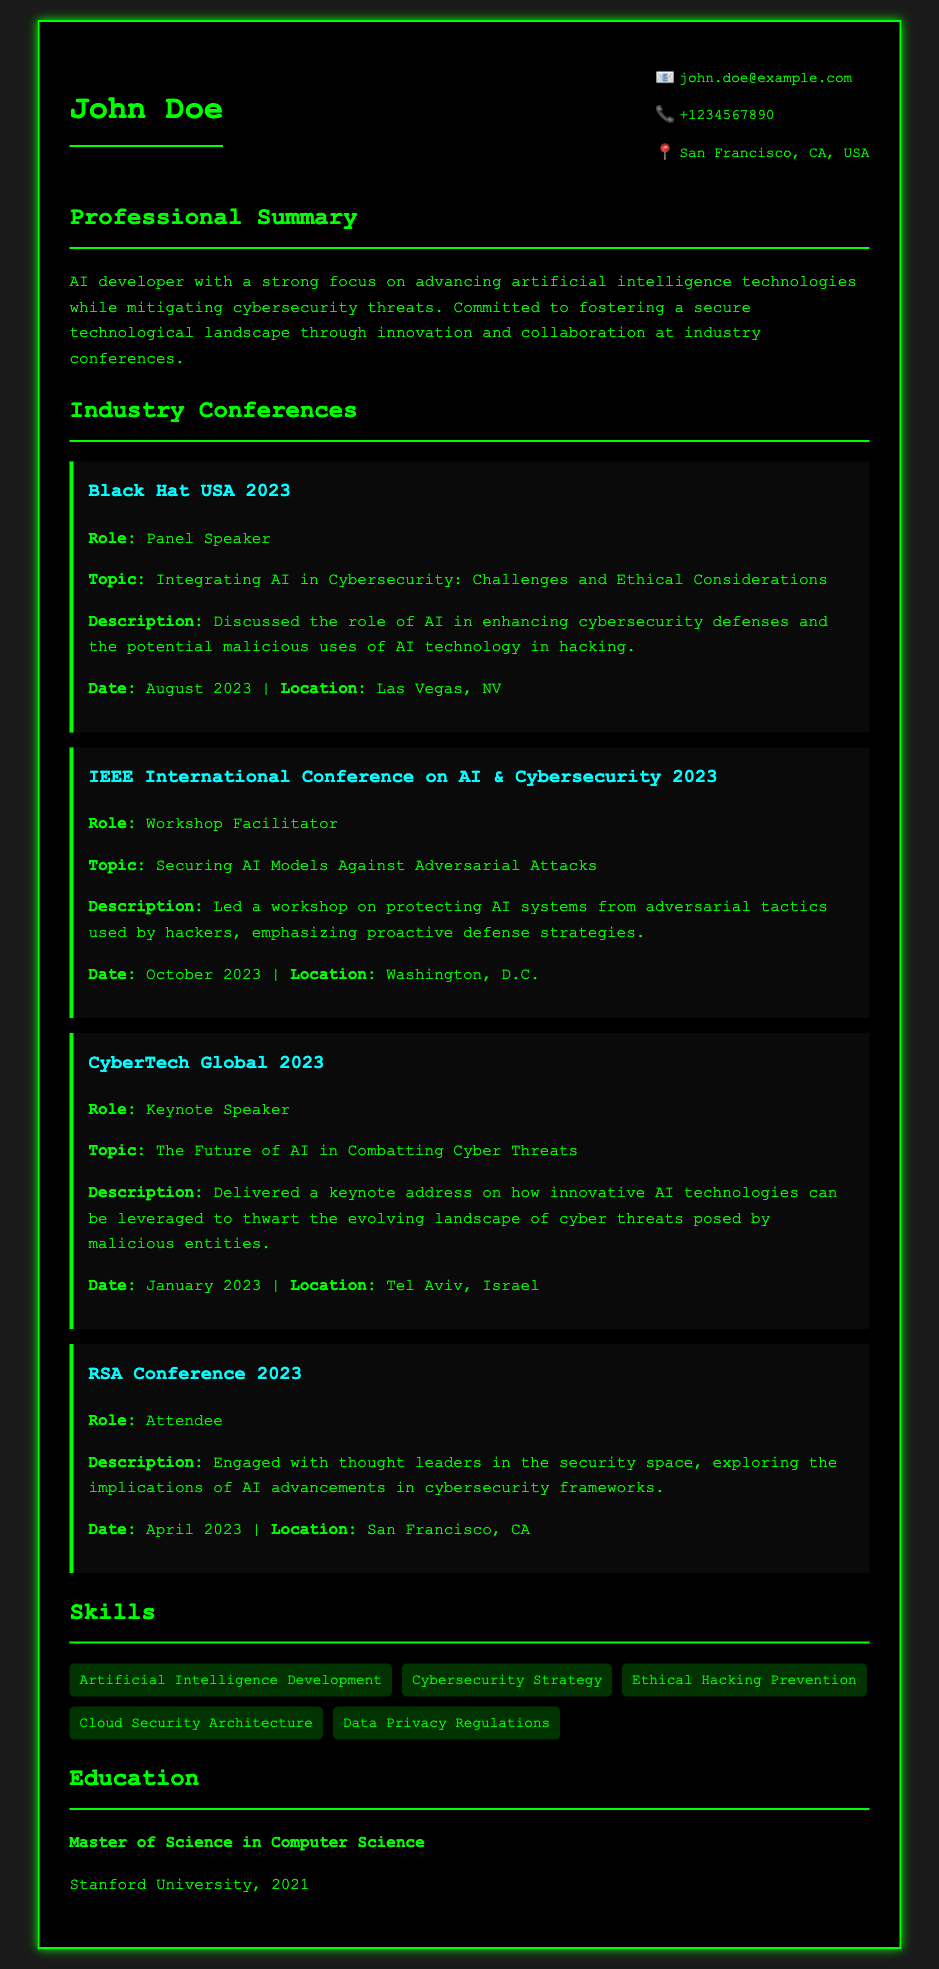what is the name of the AI developer? The document explicitly states the name of the individual at the top.
Answer: John Doe what is the role of John Doe at Black Hat USA 2023? The document specifies John Doe's role at each conference.
Answer: Panel Speaker which topic did John Doe discuss at CyberTech Global 2023? The specific topic discussed is listed under the conference section.
Answer: The Future of AI in Combatting Cyber Threats what was the date of the IEEE International Conference on AI & Cybersecurity 2023? The date for each conference is mentioned in the details.
Answer: October 2023 how many conferences did John Doe participate in during 2023? The number of listed conferences provides the count of participations throughout the year.
Answer: Four what type of session did John Doe lead at the IEEE International Conference on AI & Cybersecurity 2023? The document describes the nature of his contributions at that conference.
Answer: Workshop Facilitator where did the RSA Conference 2023 take place? The location for each conference is specified in the document.
Answer: San Francisco, CA what was the primary focus of John Doe's professional summary? The professional summary outlines his commitment and focus areas related to AI and cybersecurity.
Answer: Advancing artificial intelligence technologies while mitigating cybersecurity threats what degree did John Doe earn, and from which institution? The education section provides specific details on his academic qualifications.
Answer: Master of Science in Computer Science from Stanford University 